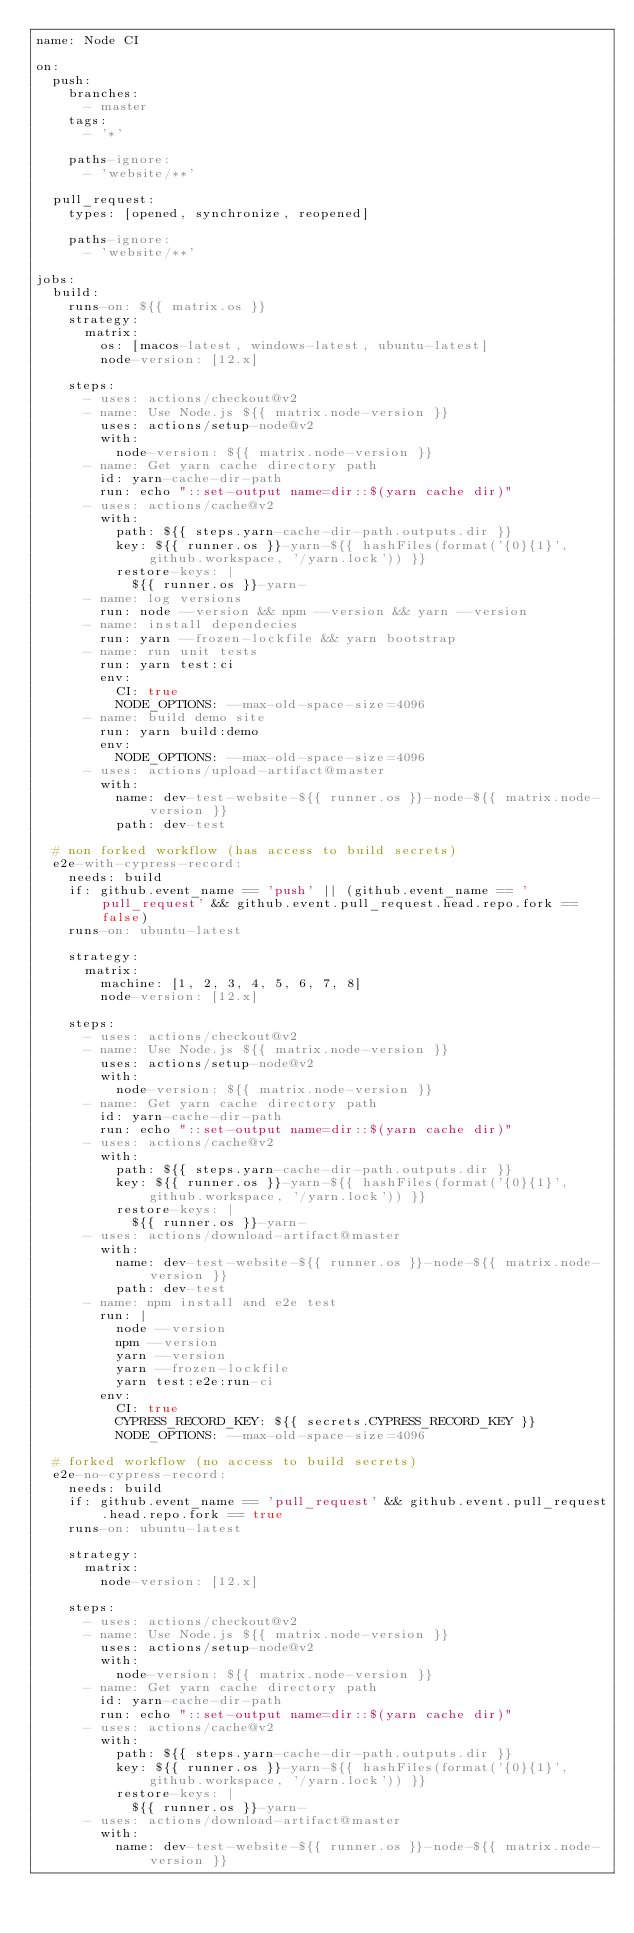<code> <loc_0><loc_0><loc_500><loc_500><_YAML_>name: Node CI

on:
  push:
    branches:
      - master
    tags:
      - '*'

    paths-ignore:
      - 'website/**'

  pull_request:
    types: [opened, synchronize, reopened]

    paths-ignore:
      - 'website/**'

jobs:
  build:
    runs-on: ${{ matrix.os }}
    strategy:
      matrix:
        os: [macos-latest, windows-latest, ubuntu-latest]
        node-version: [12.x]

    steps:
      - uses: actions/checkout@v2
      - name: Use Node.js ${{ matrix.node-version }}
        uses: actions/setup-node@v2
        with:
          node-version: ${{ matrix.node-version }}
      - name: Get yarn cache directory path
        id: yarn-cache-dir-path
        run: echo "::set-output name=dir::$(yarn cache dir)"
      - uses: actions/cache@v2
        with:
          path: ${{ steps.yarn-cache-dir-path.outputs.dir }}
          key: ${{ runner.os }}-yarn-${{ hashFiles(format('{0}{1}', github.workspace, '/yarn.lock')) }}
          restore-keys: |
            ${{ runner.os }}-yarn-
      - name: log versions
        run: node --version && npm --version && yarn --version
      - name: install dependecies
        run: yarn --frozen-lockfile && yarn bootstrap
      - name: run unit tests
        run: yarn test:ci
        env:
          CI: true
          NODE_OPTIONS: --max-old-space-size=4096
      - name: build demo site
        run: yarn build:demo
        env:
          NODE_OPTIONS: --max-old-space-size=4096
      - uses: actions/upload-artifact@master
        with:
          name: dev-test-website-${{ runner.os }}-node-${{ matrix.node-version }}
          path: dev-test

  # non forked workflow (has access to build secrets)
  e2e-with-cypress-record:
    needs: build
    if: github.event_name == 'push' || (github.event_name == 'pull_request' && github.event.pull_request.head.repo.fork == false)
    runs-on: ubuntu-latest

    strategy:
      matrix:
        machine: [1, 2, 3, 4, 5, 6, 7, 8]
        node-version: [12.x]

    steps:
      - uses: actions/checkout@v2
      - name: Use Node.js ${{ matrix.node-version }}
        uses: actions/setup-node@v2
        with:
          node-version: ${{ matrix.node-version }}
      - name: Get yarn cache directory path
        id: yarn-cache-dir-path
        run: echo "::set-output name=dir::$(yarn cache dir)"
      - uses: actions/cache@v2
        with:
          path: ${{ steps.yarn-cache-dir-path.outputs.dir }}
          key: ${{ runner.os }}-yarn-${{ hashFiles(format('{0}{1}', github.workspace, '/yarn.lock')) }}
          restore-keys: |
            ${{ runner.os }}-yarn-
      - uses: actions/download-artifact@master
        with:
          name: dev-test-website-${{ runner.os }}-node-${{ matrix.node-version }}
          path: dev-test
      - name: npm install and e2e test
        run: |
          node --version
          npm --version
          yarn --version
          yarn --frozen-lockfile
          yarn test:e2e:run-ci
        env:
          CI: true
          CYPRESS_RECORD_KEY: ${{ secrets.CYPRESS_RECORD_KEY }}
          NODE_OPTIONS: --max-old-space-size=4096

  # forked workflow (no access to build secrets)
  e2e-no-cypress-record:
    needs: build
    if: github.event_name == 'pull_request' && github.event.pull_request.head.repo.fork == true
    runs-on: ubuntu-latest

    strategy:
      matrix:
        node-version: [12.x]

    steps:
      - uses: actions/checkout@v2
      - name: Use Node.js ${{ matrix.node-version }}
        uses: actions/setup-node@v2
        with:
          node-version: ${{ matrix.node-version }}
      - name: Get yarn cache directory path
        id: yarn-cache-dir-path
        run: echo "::set-output name=dir::$(yarn cache dir)"
      - uses: actions/cache@v2
        with:
          path: ${{ steps.yarn-cache-dir-path.outputs.dir }}
          key: ${{ runner.os }}-yarn-${{ hashFiles(format('{0}{1}', github.workspace, '/yarn.lock')) }}
          restore-keys: |
            ${{ runner.os }}-yarn-
      - uses: actions/download-artifact@master
        with:
          name: dev-test-website-${{ runner.os }}-node-${{ matrix.node-version }}</code> 